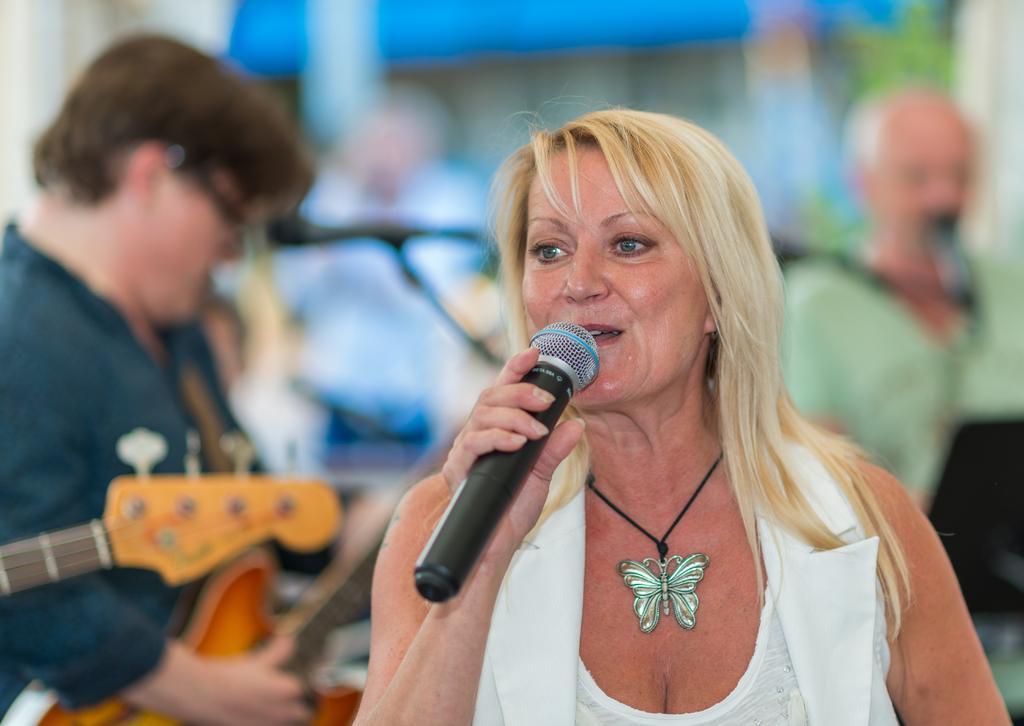Could you give a brief overview of what you see in this image? In this image there are group of people. The woman in the front holding a mic and is singing in the background the man is holding a guitar and playing it. 